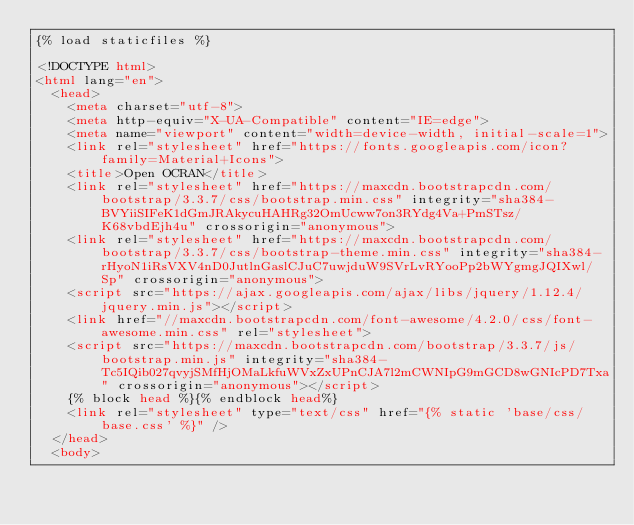<code> <loc_0><loc_0><loc_500><loc_500><_HTML_>{% load staticfiles %}

<!DOCTYPE html>
<html lang="en">
  <head>
    <meta charset="utf-8">
    <meta http-equiv="X-UA-Compatible" content="IE=edge">
    <meta name="viewport" content="width=device-width, initial-scale=1">
    <link rel="stylesheet" href="https://fonts.googleapis.com/icon?family=Material+Icons">
    <title>Open OCRAN</title>
    <link rel="stylesheet" href="https://maxcdn.bootstrapcdn.com/bootstrap/3.3.7/css/bootstrap.min.css" integrity="sha384-BVYiiSIFeK1dGmJRAkycuHAHRg32OmUcww7on3RYdg4Va+PmSTsz/K68vbdEjh4u" crossorigin="anonymous">
    <link rel="stylesheet" href="https://maxcdn.bootstrapcdn.com/bootstrap/3.3.7/css/bootstrap-theme.min.css" integrity="sha384-rHyoN1iRsVXV4nD0JutlnGaslCJuC7uwjduW9SVrLvRYooPp2bWYgmgJQIXwl/Sp" crossorigin="anonymous">
    <script src="https://ajax.googleapis.com/ajax/libs/jquery/1.12.4/jquery.min.js"></script>
    <link href="//maxcdn.bootstrapcdn.com/font-awesome/4.2.0/css/font-awesome.min.css" rel="stylesheet">
    <script src="https://maxcdn.bootstrapcdn.com/bootstrap/3.3.7/js/bootstrap.min.js" integrity="sha384-Tc5IQib027qvyjSMfHjOMaLkfuWVxZxUPnCJA7l2mCWNIpG9mGCD8wGNIcPD7Txa" crossorigin="anonymous"></script>
    {% block head %}{% endblock head%}
    <link rel="stylesheet" type="text/css" href="{% static 'base/css/base.css' %}" />
  </head>
  <body></code> 